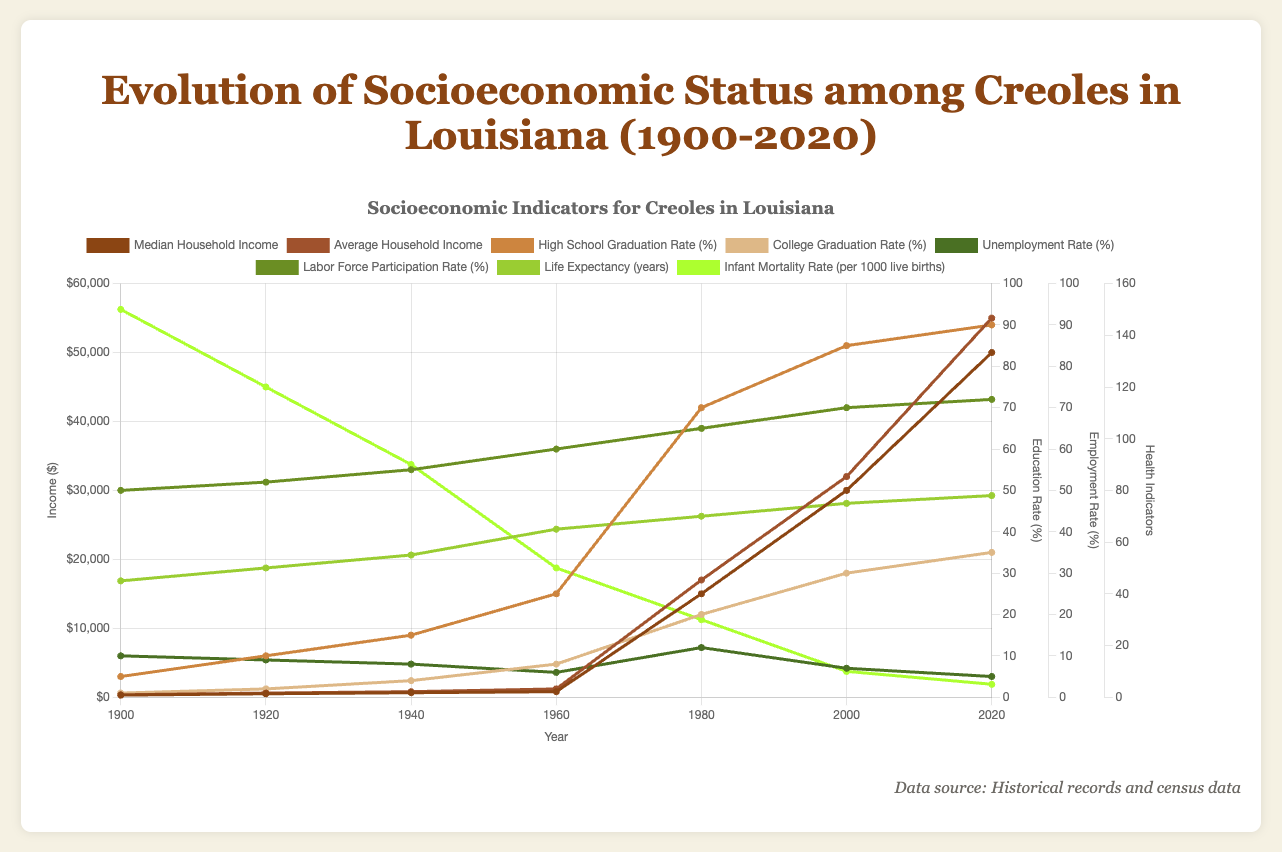What is the difference between the Median Household Income in 1920 and 2020? To find the difference, subtract the 1920 value from the 2020 value. The Median Household Income in 1920 is $500 and in 2020 is $50,000. The difference is $50,000 - $500 = $49,500
Answer: $49,500 How did the Life Expectancy change from 1900 to 2020? Subtract the Life Expectancy in 1900 from the Life Expectancy in 2020. In 1900, it was 45 years, and in 2020, it is 78 years. The change is 78 - 45 = 33 years
Answer: 33 years Which has a higher value in 1940, the High School Graduation Rate or the College Graduation Rate? Compare the values for 1940 from the education data. The High School Graduation Rate in 1940 is 15%, and the College Graduation Rate is 4%. Since 15% is greater than 4%, the High School Graduation Rate is higher
Answer: High School Graduation Rate Between which two decades did the Unemployment Rate decrease the most? Calculate the difference in Unemployment Rates between each consecutive pair of decades. Largest decrease is between 1980 (12%) and 2000 (7%), which is 12% - 7% = 5%
Answer: 1980 to 2000 What trends do you observe in the Infant Mortality Rate from 1900 to 2020? Observe the sequential decrease over the years. The Infant Mortality Rate declines from 150 per 1000 live births in 1900 to 5 per 1000 live births in 2020. This shows a consistent downward trend over the years
Answer: Consistent downward trend How did the Average Household Income in 2000 compare to the Median Household Income in the same year? Check the values for 2000. Average Household Income is $32,000, while Median Household Income is $30,000. Since $32,000 is greater than $30,000, the Average Household Income is higher
Answer: Average Household Income is higher Which year shows the highest Labor Force Participation Rate? Look at the values for the Labor Force Participation Rate. The highest value is in 2020, at 72%
Answer: 2020 What is the percentage increase in High School Graduation Rate from 1980 to 2020? Calculate the percentage increase: ((90 - 70) / 70) * 100. First, find the absolute increase, 90 - 70 = 20. Then, (20 / 70) * 100 ≈ 28.57%
Answer: 28.57% In which decade did the College Graduation Rate surpass 25%? Look at the values for College Graduation Rate. It surpassed 25% by 2000, reaching 30%
Answer: 2000 How did the Unemployment Rate in 2020 compare to 1900? The Unemployment Rate in 2020 is 5%, whereas in 1900 it was 10%. Since 5% is less than 10%, the Unemployment Rate decreased
Answer: Decreased 